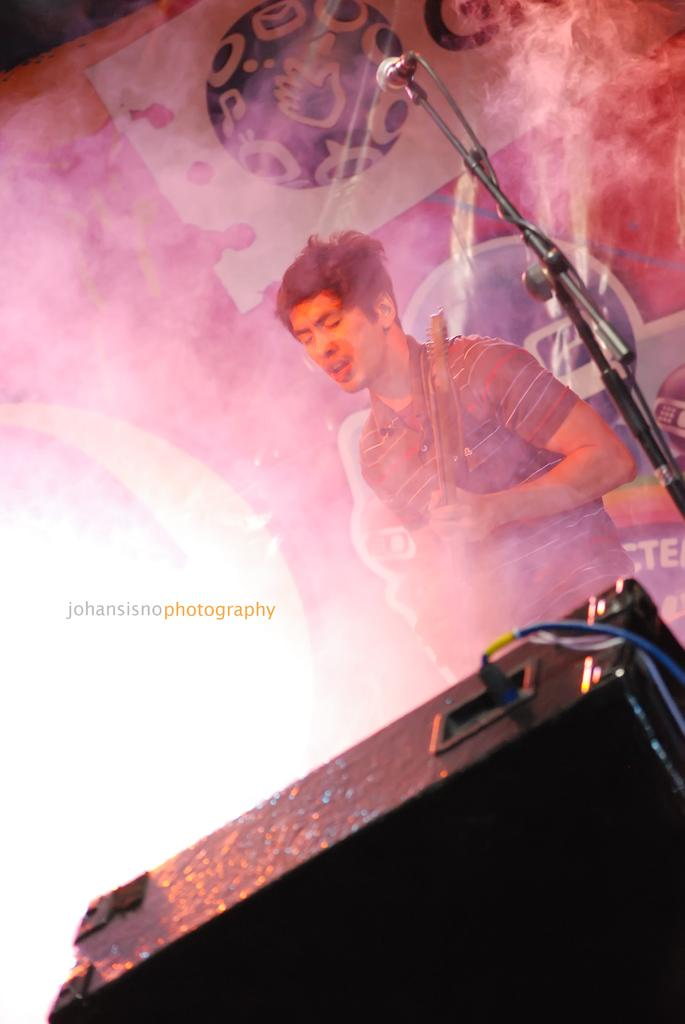What is the person in the image doing? The person is standing in the image and holding something. What object can be seen in the person's hand? The person is holding a microphone in the image. What other objects are present in the image? There is a stand, a speaker, a wire, and a colorful banner in the image. What might the person be using the microphone for? The person might be using the microphone for speaking or performing in front of an audience. What type of shirt is the egg wearing in the image? There is no egg present in the image, and therefore no shirt can be attributed to it. 